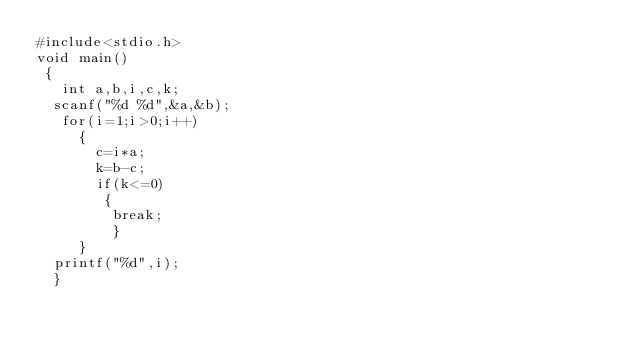Convert code to text. <code><loc_0><loc_0><loc_500><loc_500><_C_>#include<stdio.h>
void main() 
 {  
   int a,b,i,c,k;
  scanf("%d %d",&a,&b);
   for(i=1;i>0;i++)
     { 
       c=i*a;
       k=b-c;
       if(k<=0)
        { 
         break;
         } 
     } 
  printf("%d",i);
  }
  
</code> 